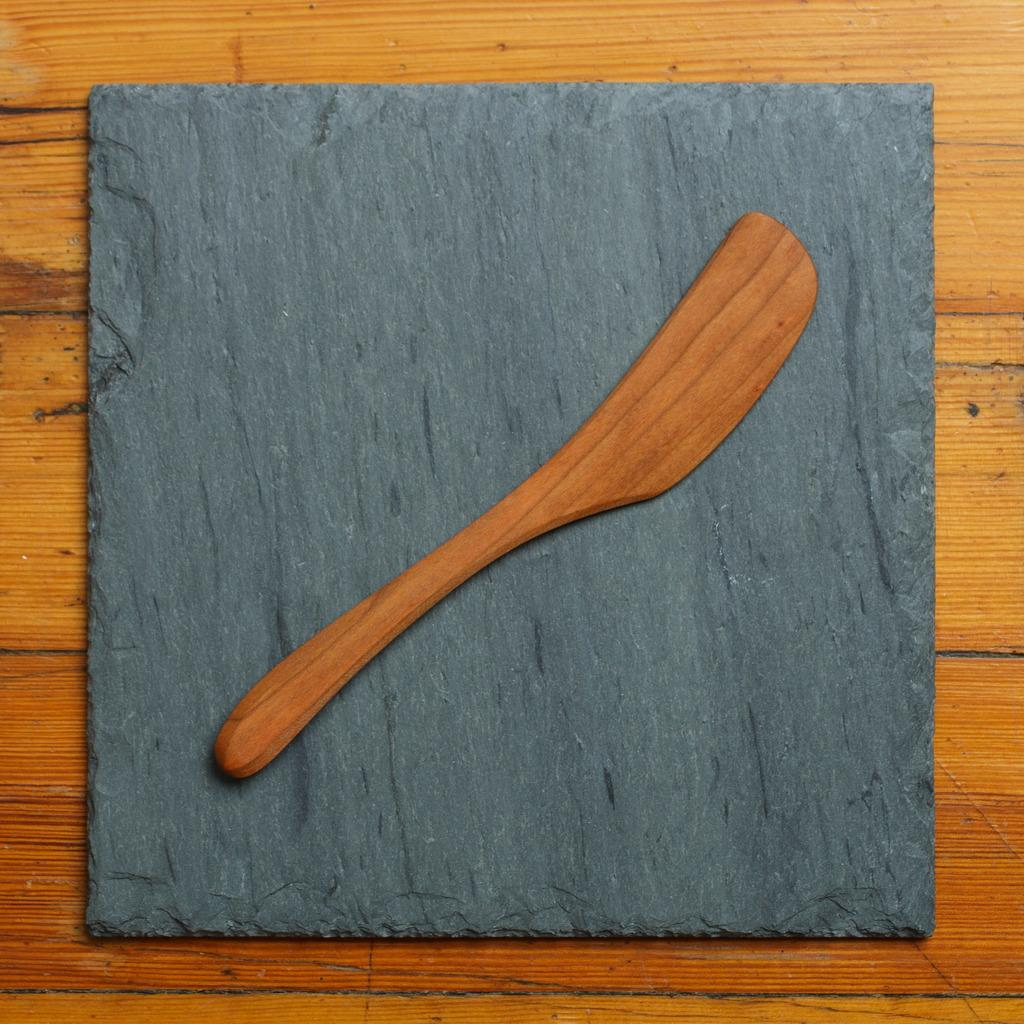What object is visible in the image that is made of wood? There is a wooden spatula in the image. What type of surface is the wooden spatula resting on? The wooden spatula is on a marble surface. What material is the surface that the wooden spatula is on made of? The marble surface is placed on a wooden object. What type of sound can be heard coming from the wooden spatula in the image? There is no sound coming from the wooden spatula in the image, as it is a static object. 